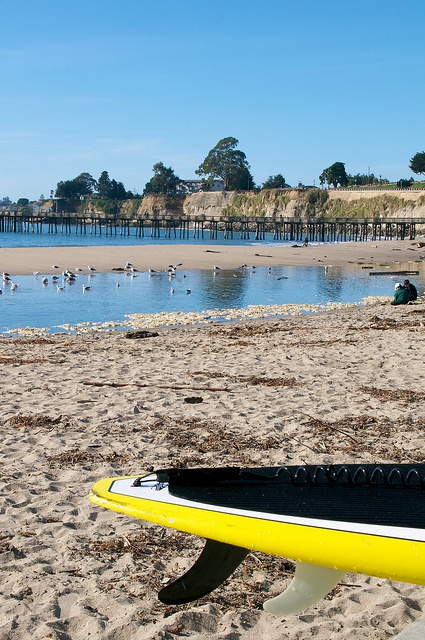Describe the objects in this image and their specific colors. I can see surfboard in lightblue, black, yellow, white, and olive tones, bird in lightblue, darkgray, and gray tones, people in lightblue, black, teal, white, and darkgray tones, people in lightblue, black, gray, navy, and maroon tones, and bird in lightblue, black, white, darkgray, and gray tones in this image. 